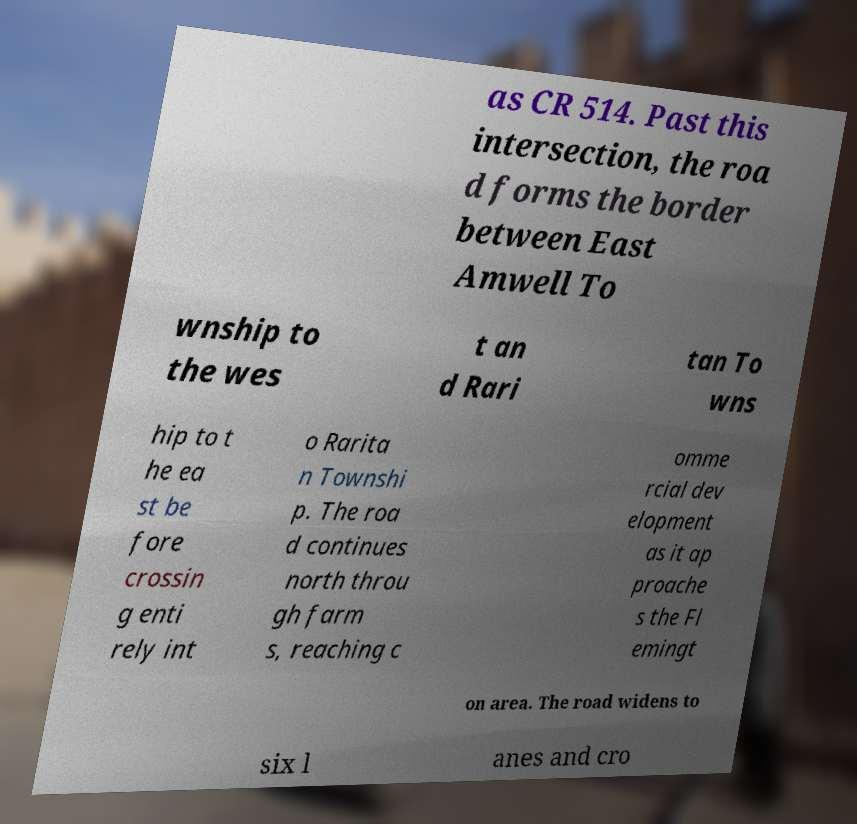Can you accurately transcribe the text from the provided image for me? as CR 514. Past this intersection, the roa d forms the border between East Amwell To wnship to the wes t an d Rari tan To wns hip to t he ea st be fore crossin g enti rely int o Rarita n Townshi p. The roa d continues north throu gh farm s, reaching c omme rcial dev elopment as it ap proache s the Fl emingt on area. The road widens to six l anes and cro 